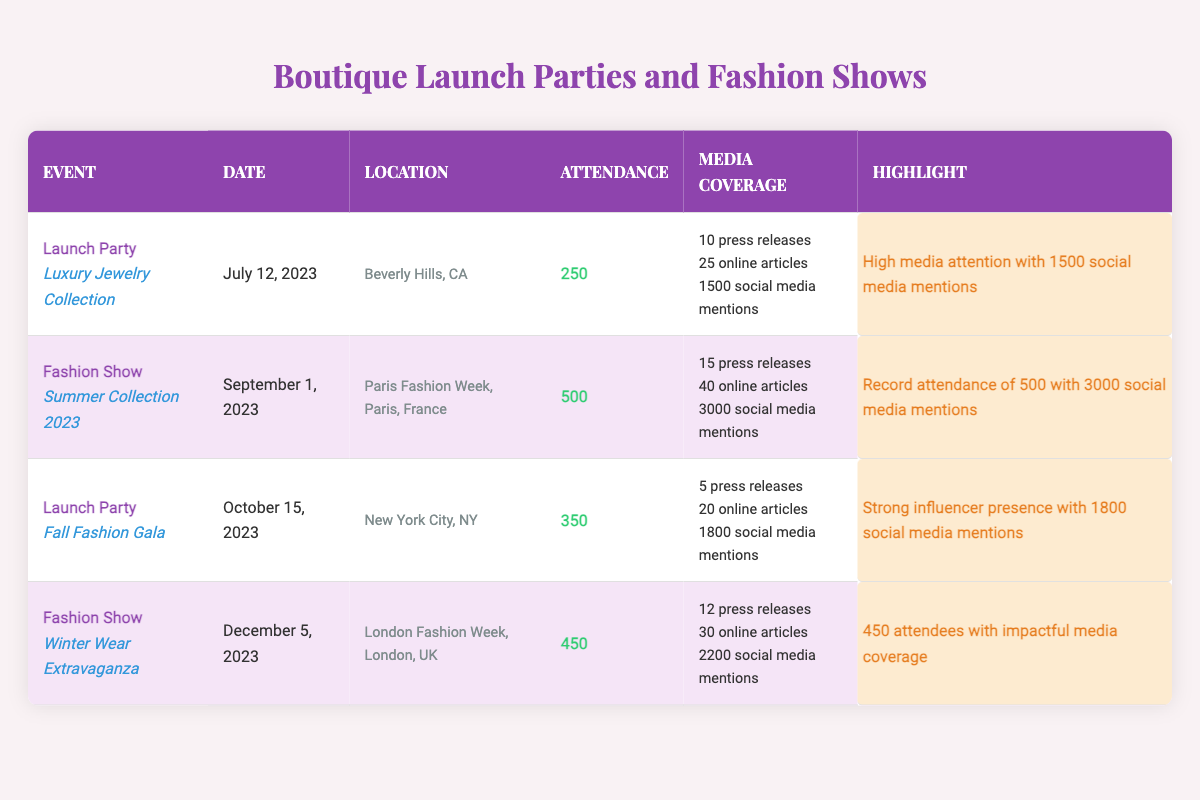What is the attendance for the "Luxury Jewelry Collection" launch party? The attendance value listed for the "Luxury Jewelry Collection" launch party in the table is 250.
Answer: 250 How many social media mentions did the "Summer Collection 2023" fashion show receive? The "Summer Collection 2023" fashion show has 3000 social media mentions as stated in the media coverage section.
Answer: 3000 Which event had the highest attendance? The event with the highest attendance is the "Summer Collection 2023" fashion show with 500 attendees, which is compared to other events in the table.
Answer: 500 What is the total number of press releases for all events listed? Adding the number of press releases: 10 + 15 + 5 + 12 gives us a total of 42 press releases.
Answer: 42 Did the "Fall Fashion Gala" receive more social media mentions than the "Luxury Jewelry Collection" launch party? The "Fall Fashion Gala" received 1800 social media mentions, while the "Luxury Jewelry Collection" had 1500 social media mentions, making this statement true.
Answer: Yes What is the average attendance across all events? The attendance values are 250, 500, 350, and 450, summing these gives 250 + 500 + 350 + 450 = 1550. Dividing by the number of events (4) results in an average of 1550/4 = 387.5.
Answer: 387.5 Which event had the highest media coverage in terms of online articles? The "Summer Collection 2023" fashion show had the highest media coverage with 40 online articles compared to others.
Answer: 40 Is there an event that had exactly 1800 social media mentions? Yes, the "Fall Fashion Gala" had exactly 1800 social media mentions as per the data in the table.
Answer: Yes What is the difference in attendance between the "Winter Wear Extravaganza" and the "Fall Fashion Gala"? The "Winter Wear Extravaganza" has 450 attendees and the "Fall Fashion Gala" has 350 attendees; thus, 450 - 350 = 100.
Answer: 100 How many influencers were mentioned for the "Luxury Jewelry Collection" launch party? The "Luxury Jewelry Collection" launch party had 2 influencers mentioned: @ChicFashionista and @GlamStyler.
Answer: 2 